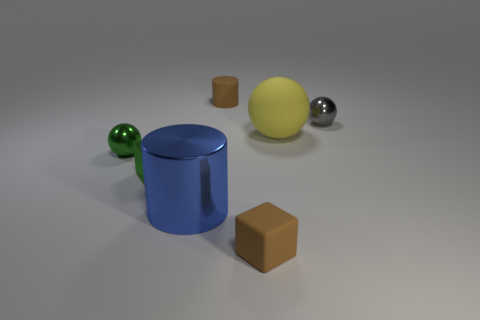The cube that is made of the same material as the large blue thing is what color?
Keep it short and to the point. Green. There is a small metal ball that is to the left of the small metal ball that is behind the large yellow matte thing; how many blue things are behind it?
Keep it short and to the point. 0. There is a small block that is the same color as the tiny cylinder; what material is it?
Ensure brevity in your answer.  Rubber. Is there any other thing that has the same shape as the gray metallic thing?
Keep it short and to the point. Yes. What number of objects are small objects that are behind the blue cylinder or small gray things?
Ensure brevity in your answer.  4. Do the metal ball right of the large sphere and the large metallic object have the same color?
Your response must be concise. No. What shape is the tiny brown thing right of the tiny matte thing that is behind the small brown block?
Keep it short and to the point. Cube. Is the number of big cylinders on the right side of the yellow rubber object less than the number of tiny gray things that are in front of the gray object?
Provide a short and direct response. No. There is another metal thing that is the same shape as the gray metal object; what is its size?
Provide a short and direct response. Small. Are there any other things that have the same size as the brown block?
Your answer should be compact. Yes. 